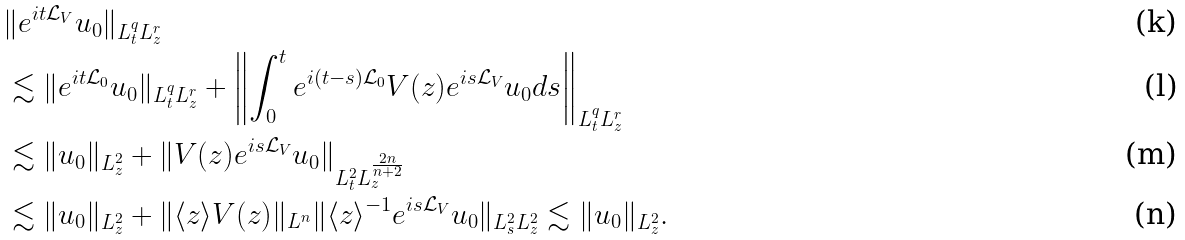Convert formula to latex. <formula><loc_0><loc_0><loc_500><loc_500>& \| e ^ { i t \mathcal { L } _ { V } } u _ { 0 } \| _ { L ^ { q } _ { t } L ^ { r } _ { z } } \\ & \lesssim \| e ^ { i t \mathcal { L } _ { 0 } } u _ { 0 } \| _ { L ^ { q } _ { t } L ^ { r } _ { z } } + \left \| \int _ { 0 } ^ { t } e ^ { i ( t - s ) \mathcal { L } _ { 0 } } V ( z ) e ^ { i s \mathcal { L } _ { V } } u _ { 0 } d s \right \| _ { L ^ { q } _ { t } L ^ { r } _ { z } } \\ & \lesssim \| u _ { 0 } \| _ { L ^ { 2 } _ { z } } + \| V ( z ) e ^ { i s \mathcal { L } _ { V } } u _ { 0 } \| _ { L ^ { 2 } _ { t } L ^ { \frac { 2 n } { n + 2 } } _ { z } } \\ & \lesssim \| u _ { 0 } \| _ { L ^ { 2 } _ { z } } + \| \langle z \rangle V ( z ) \| _ { L ^ { n } } \| \langle z \rangle ^ { - 1 } e ^ { i s \mathcal { L } _ { V } } u _ { 0 } \| _ { L ^ { 2 } _ { s } L ^ { 2 } _ { z } } \lesssim \| u _ { 0 } \| _ { L ^ { 2 } _ { z } } .</formula> 